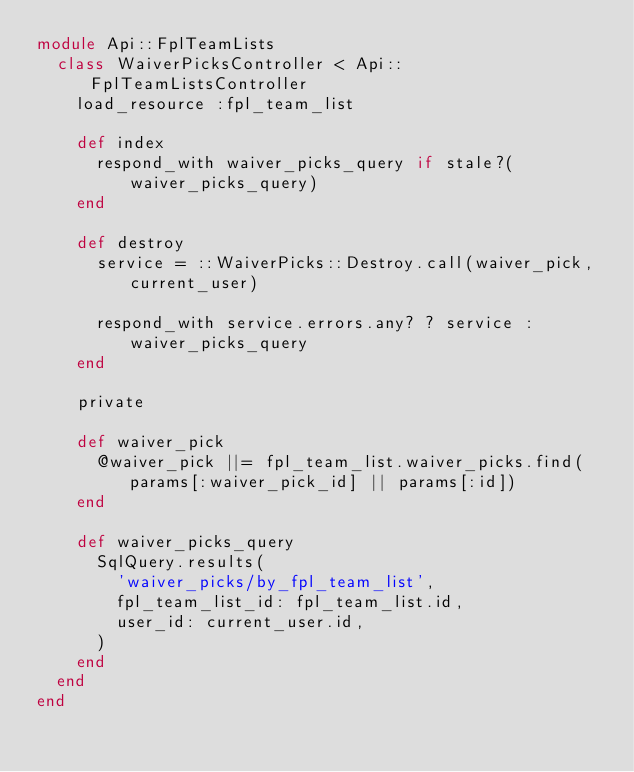Convert code to text. <code><loc_0><loc_0><loc_500><loc_500><_Ruby_>module Api::FplTeamLists
  class WaiverPicksController < Api::FplTeamListsController
    load_resource :fpl_team_list

    def index
      respond_with waiver_picks_query if stale?(waiver_picks_query)
    end

    def destroy
      service = ::WaiverPicks::Destroy.call(waiver_pick, current_user)

      respond_with service.errors.any? ? service : waiver_picks_query
    end

    private

    def waiver_pick
      @waiver_pick ||= fpl_team_list.waiver_picks.find(params[:waiver_pick_id] || params[:id])
    end

    def waiver_picks_query
      SqlQuery.results(
        'waiver_picks/by_fpl_team_list',
        fpl_team_list_id: fpl_team_list.id,
        user_id: current_user.id,
      )
    end
  end
end
</code> 